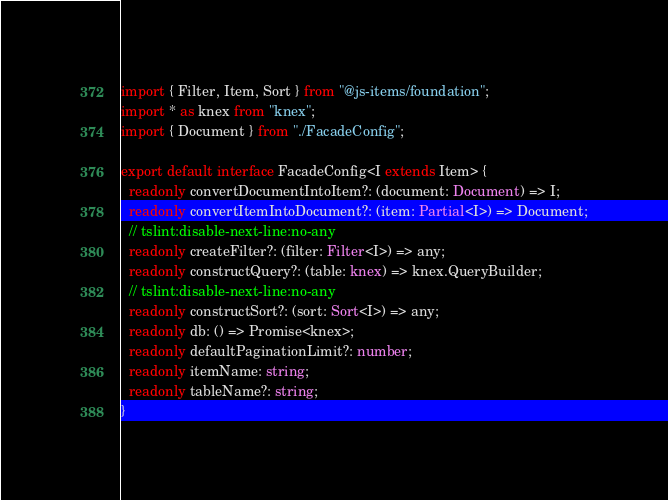<code> <loc_0><loc_0><loc_500><loc_500><_TypeScript_>import { Filter, Item, Sort } from "@js-items/foundation";
import * as knex from "knex";
import { Document } from "./FacadeConfig";

export default interface FacadeConfig<I extends Item> {
  readonly convertDocumentIntoItem?: (document: Document) => I;
  readonly convertItemIntoDocument?: (item: Partial<I>) => Document;
  // tslint:disable-next-line:no-any
  readonly createFilter?: (filter: Filter<I>) => any;
  readonly constructQuery?: (table: knex) => knex.QueryBuilder;
  // tslint:disable-next-line:no-any
  readonly constructSort?: (sort: Sort<I>) => any;
  readonly db: () => Promise<knex>;
  readonly defaultPaginationLimit?: number;
  readonly itemName: string;
  readonly tableName?: string;
}
</code> 